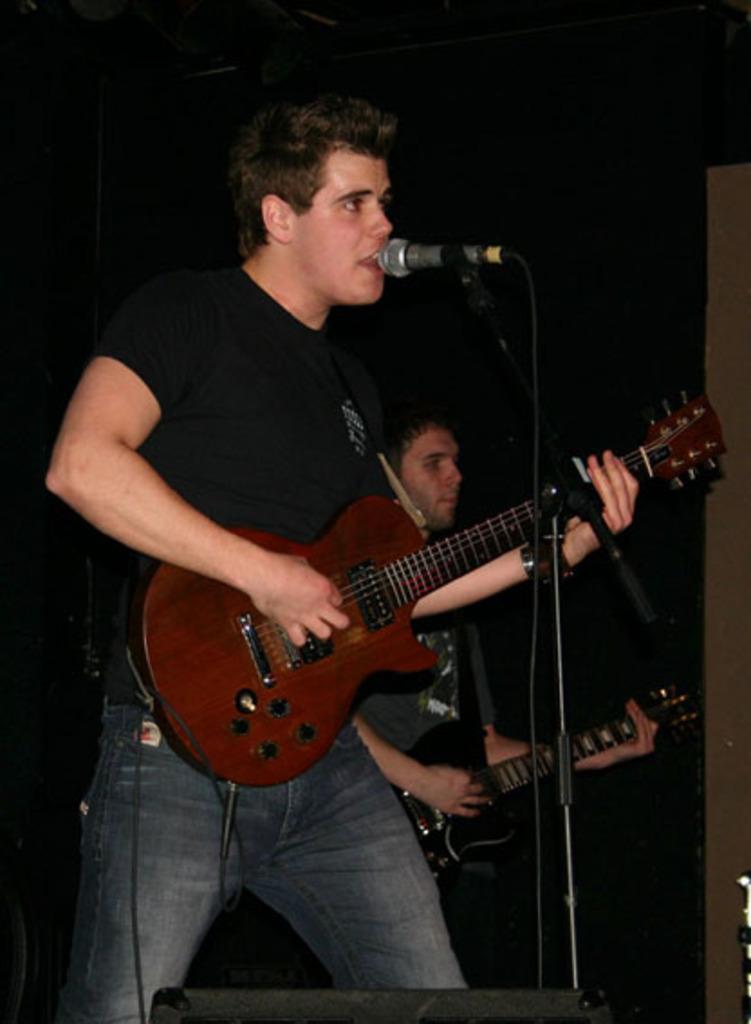Can you describe this image briefly? There is a man in black color dress, singing and playing a guitar. In the background, there is a man in gray color dress, playing guitar. In front of this man, there is a mic and stand. 